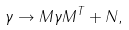<formula> <loc_0><loc_0><loc_500><loc_500>\gamma \rightarrow M \gamma M ^ { T } + N ,</formula> 